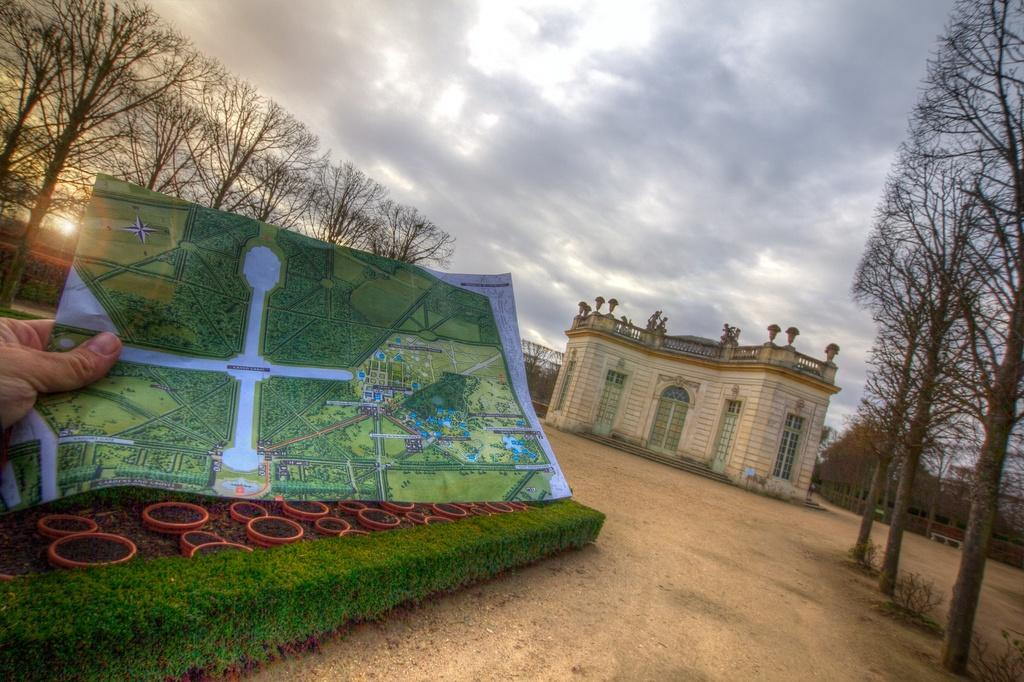What type of structure is visible in the image? There is a building in the image. What is the person in the image doing? The person is catching papers in the image. What type of vegetation can be seen in the image? There are trees and plants in the image. How would you describe the weather in the image? The sky is cloudy in the image, which suggests a partly cloudy or overcast day. Where is the group of people waiting for the train in the image? There is no group of people or train present in the image. 